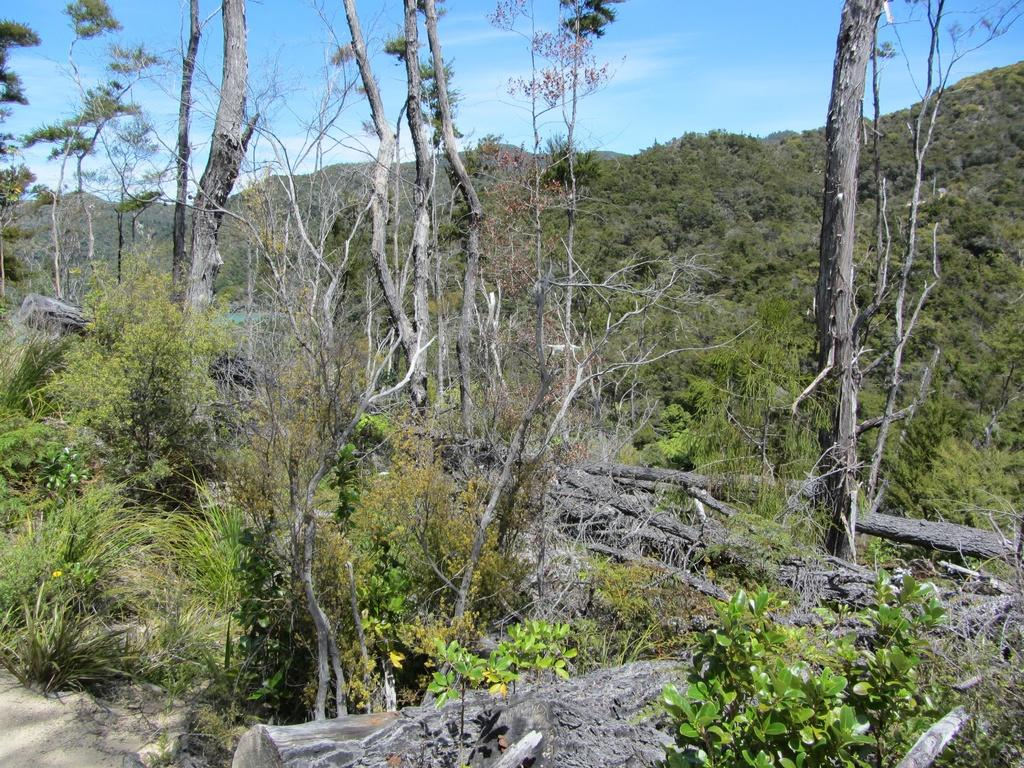What type of vegetation can be seen in the image? There are plants and trees in the image. Can you describe the trunks of the trees in the image? Tree trunks are visible in the image. What type of landscape feature is present in the image? There are hills in the image. Where is the kitten sitting on the plate in the image? There is no kitten or plate present in the image. What type of lead is used to guide the plants in the image? There is no lead present in the image; the plants are growing naturally. 